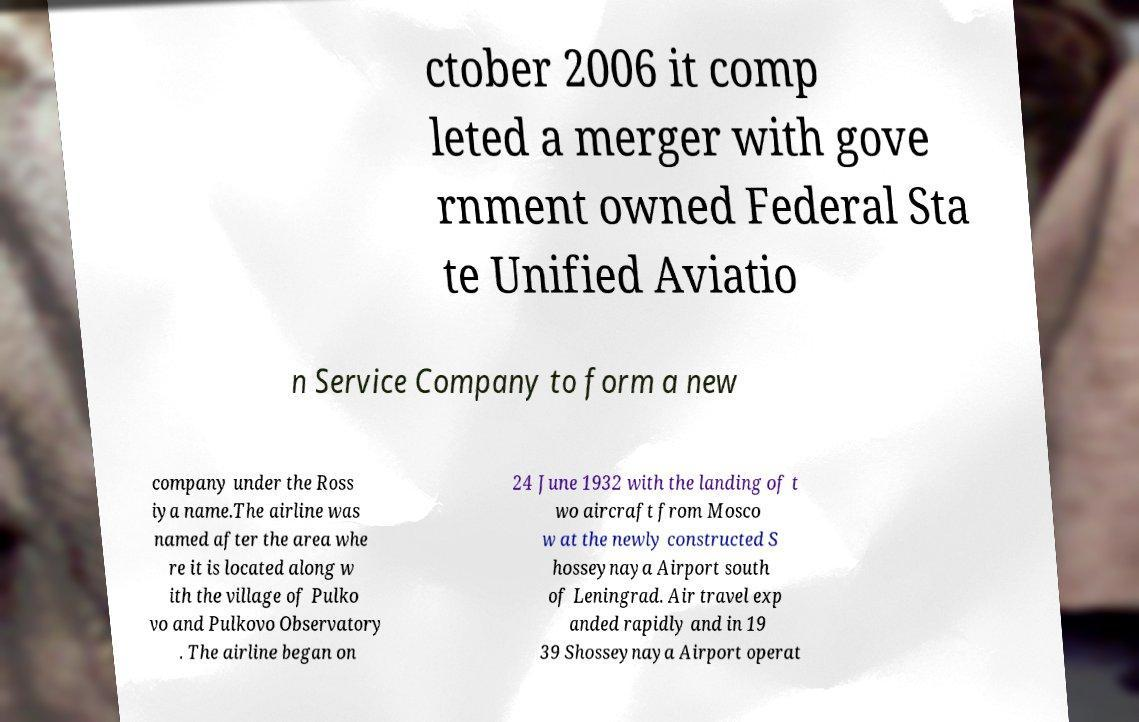Could you extract and type out the text from this image? ctober 2006 it comp leted a merger with gove rnment owned Federal Sta te Unified Aviatio n Service Company to form a new company under the Ross iya name.The airline was named after the area whe re it is located along w ith the village of Pulko vo and Pulkovo Observatory . The airline began on 24 June 1932 with the landing of t wo aircraft from Mosco w at the newly constructed S hosseynaya Airport south of Leningrad. Air travel exp anded rapidly and in 19 39 Shosseynaya Airport operat 